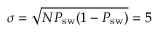Convert formula to latex. <formula><loc_0><loc_0><loc_500><loc_500>\sigma = \sqrt { N P _ { s w } ( 1 - P _ { s w } ) } = 5</formula> 